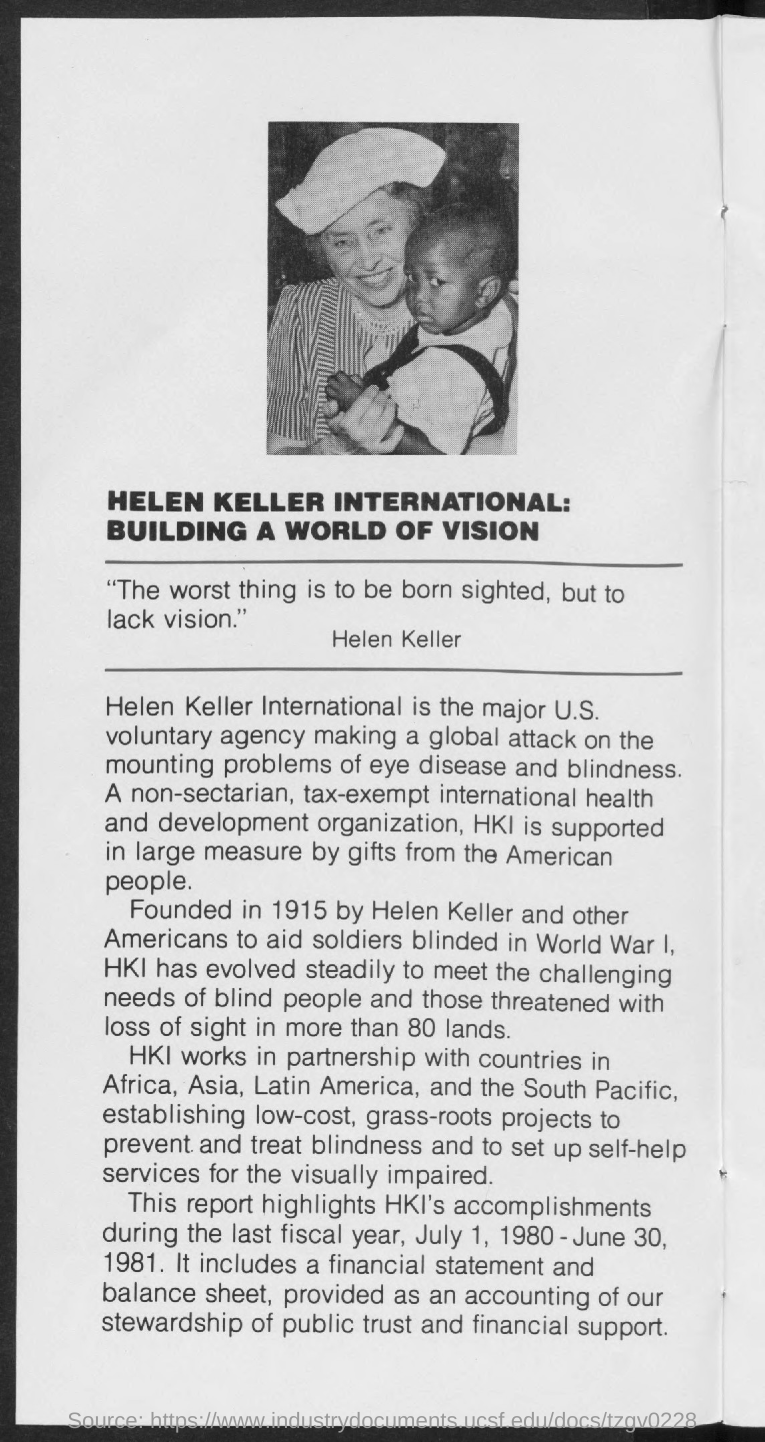Mention a couple of crucial points in this snapshot. Helen Keller, in the given document, stated that the worst thing is to be born sighted but to lack vision. HKI's accomplishments were reported for the time period of July 1, 1980 to June 30, 1981. The HKI is largely supported by the generosity of American people. 